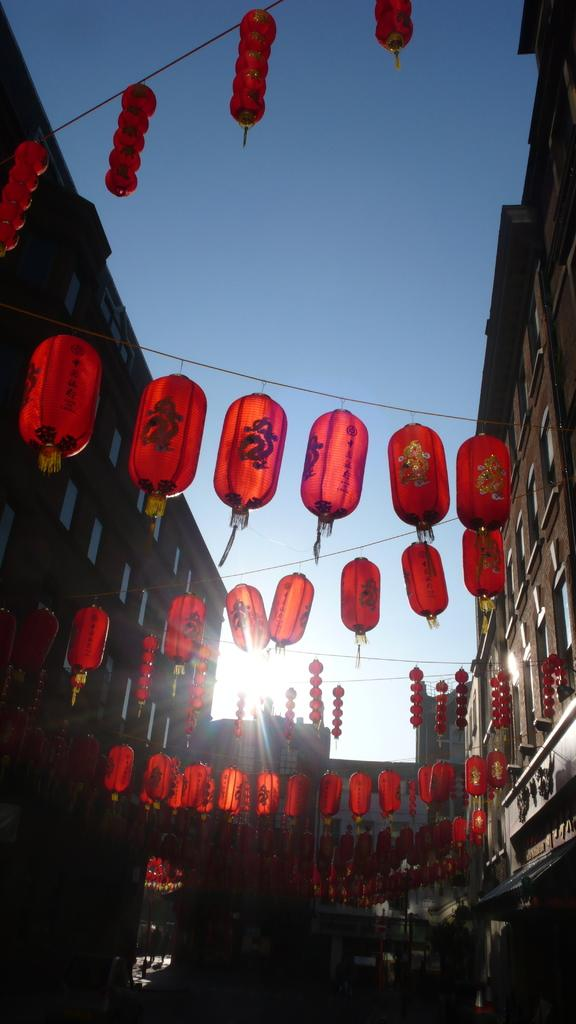What type of structures can be seen in the image? There are buildings in the image. What is attached to the wires in the image? There are red color objects attached to the wires in the image. Can you describe any other objects present in the image? Yes, there are other objects in the image. What is visible in the background of the image? The sun and the sky are visible in the background of the image. What type of songs can be heard in the image? There is no audio component in the image, so it is not possible to determine what songs might be heard. 